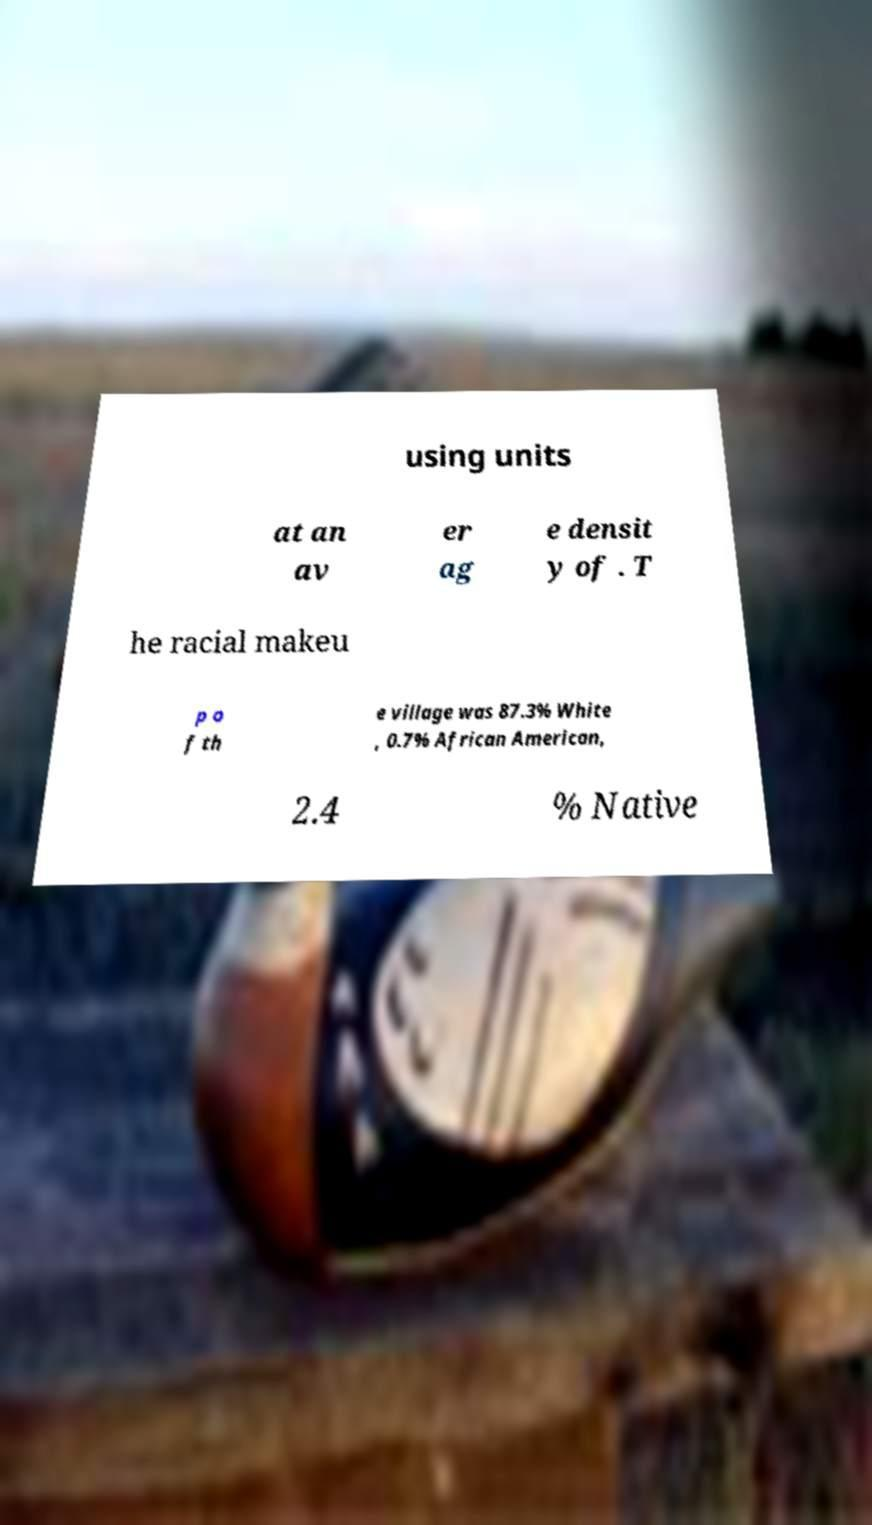Please identify and transcribe the text found in this image. using units at an av er ag e densit y of . T he racial makeu p o f th e village was 87.3% White , 0.7% African American, 2.4 % Native 